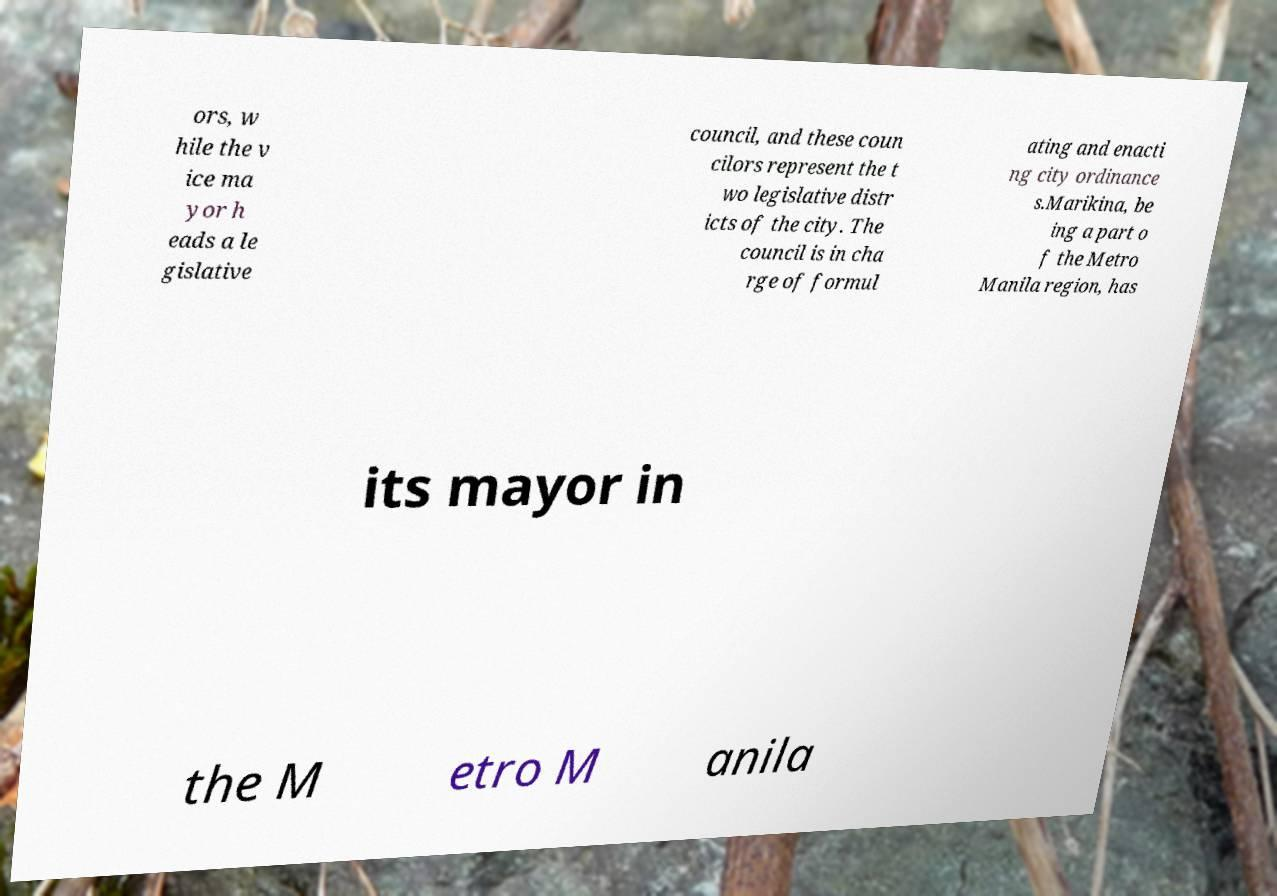Please identify and transcribe the text found in this image. ors, w hile the v ice ma yor h eads a le gislative council, and these coun cilors represent the t wo legislative distr icts of the city. The council is in cha rge of formul ating and enacti ng city ordinance s.Marikina, be ing a part o f the Metro Manila region, has its mayor in the M etro M anila 